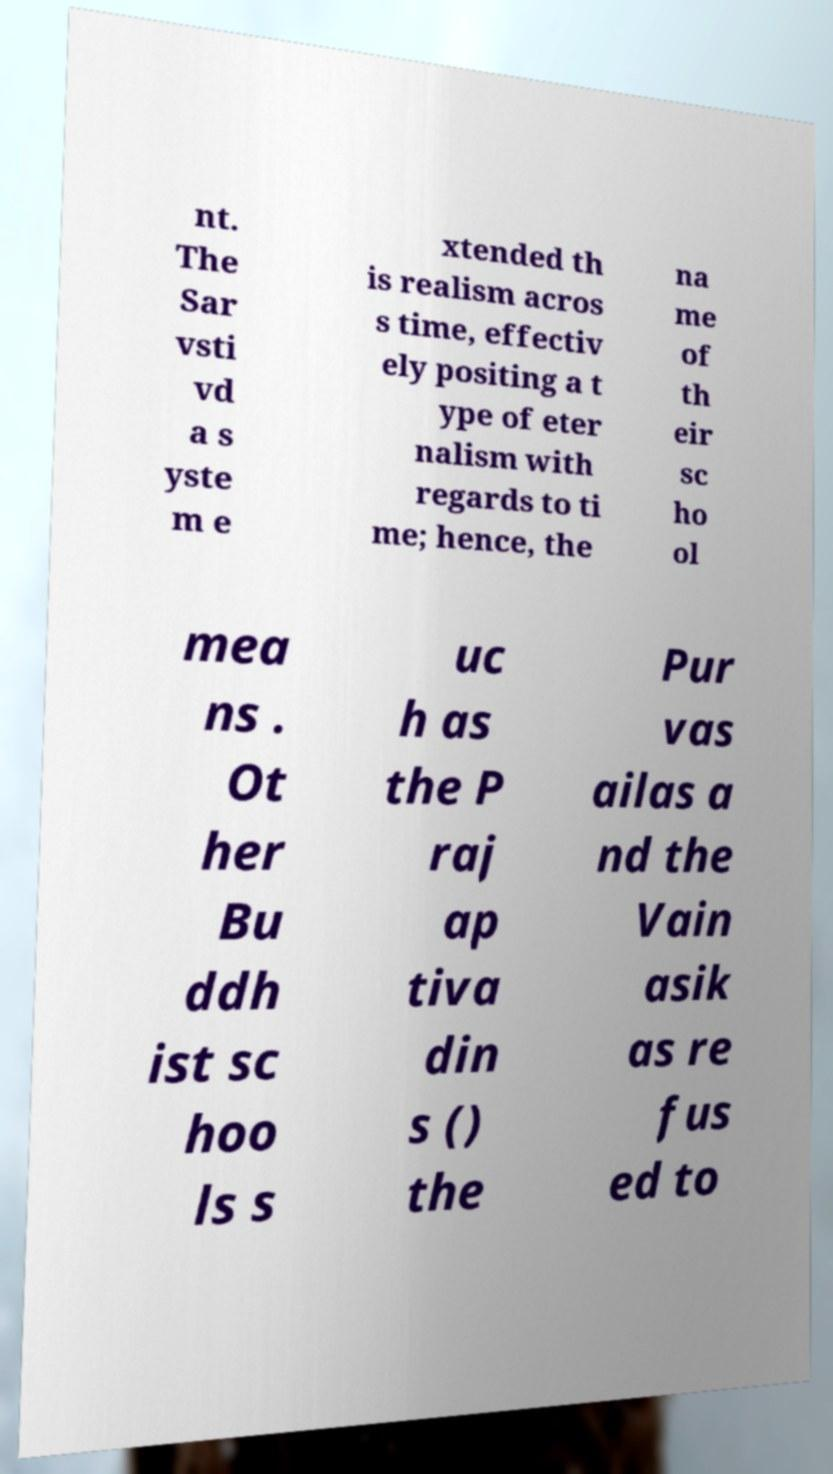Please read and relay the text visible in this image. What does it say? nt. The Sar vsti vd a s yste m e xtended th is realism acros s time, effectiv ely positing a t ype of eter nalism with regards to ti me; hence, the na me of th eir sc ho ol mea ns . Ot her Bu ddh ist sc hoo ls s uc h as the P raj ap tiva din s () the Pur vas ailas a nd the Vain asik as re fus ed to 